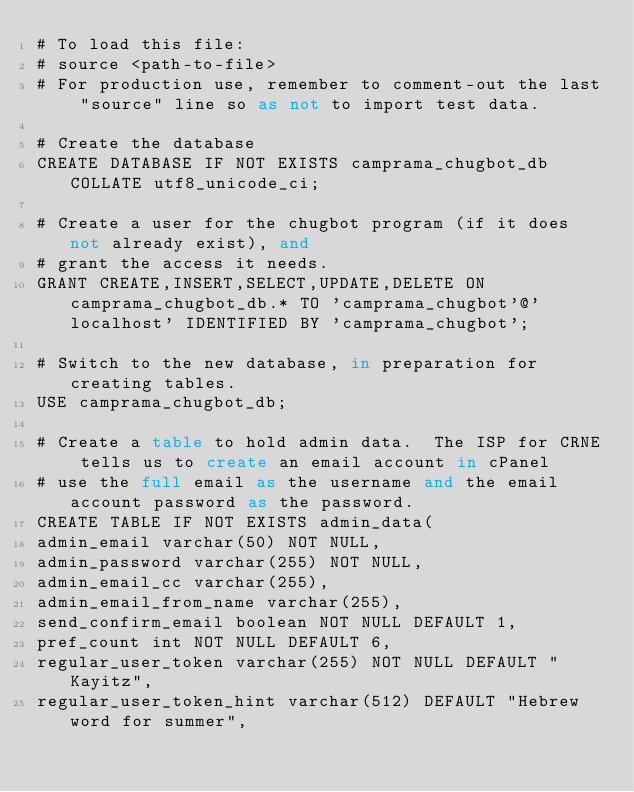Convert code to text. <code><loc_0><loc_0><loc_500><loc_500><_SQL_># To load this file:
# source <path-to-file>
# For production use, remember to comment-out the last "source" line so as not to import test data.

# Create the database
CREATE DATABASE IF NOT EXISTS camprama_chugbot_db COLLATE utf8_unicode_ci;

# Create a user for the chugbot program (if it does not already exist), and
# grant the access it needs.
GRANT CREATE,INSERT,SELECT,UPDATE,DELETE ON camprama_chugbot_db.* TO 'camprama_chugbot'@'localhost' IDENTIFIED BY 'camprama_chugbot';

# Switch to the new database, in preparation for creating tables.
USE camprama_chugbot_db;

# Create a table to hold admin data.  The ISP for CRNE tells us to create an email account in cPanel
# use the full email as the username and the email account password as the password.
CREATE TABLE IF NOT EXISTS admin_data(
admin_email varchar(50) NOT NULL,
admin_password varchar(255) NOT NULL,
admin_email_cc varchar(255),
admin_email_from_name varchar(255),
send_confirm_email boolean NOT NULL DEFAULT 1,
pref_count int NOT NULL DEFAULT 6,
regular_user_token varchar(255) NOT NULL DEFAULT "Kayitz",
regular_user_token_hint varchar(512) DEFAULT "Hebrew word for summer",</code> 